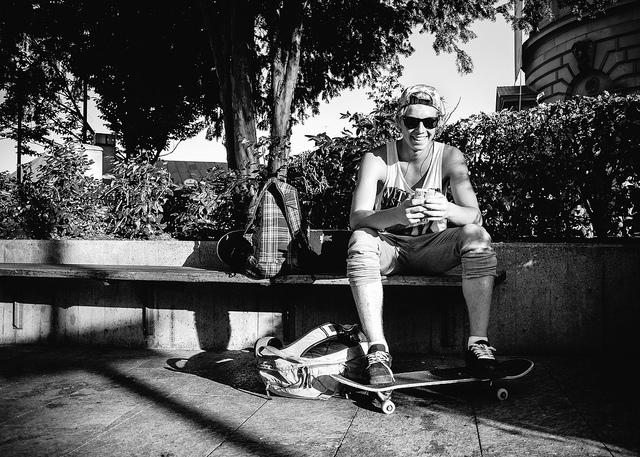What's the man taking a break from? skateboarding 